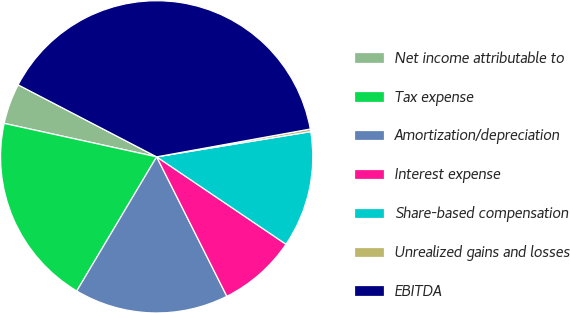<chart> <loc_0><loc_0><loc_500><loc_500><pie_chart><fcel>Net income attributable to<fcel>Tax expense<fcel>Amortization/depreciation<fcel>Interest expense<fcel>Share-based compensation<fcel>Unrealized gains and losses<fcel>EBITDA<nl><fcel>4.19%<fcel>19.89%<fcel>15.97%<fcel>8.12%<fcel>12.04%<fcel>0.27%<fcel>39.52%<nl></chart> 